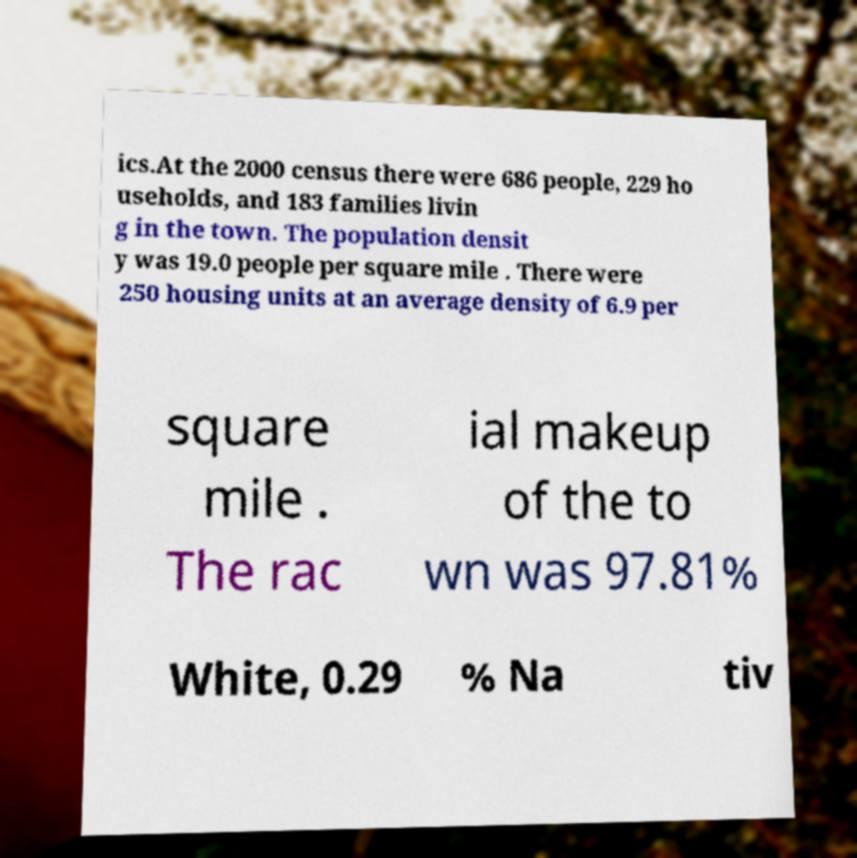Can you read and provide the text displayed in the image?This photo seems to have some interesting text. Can you extract and type it out for me? ics.At the 2000 census there were 686 people, 229 ho useholds, and 183 families livin g in the town. The population densit y was 19.0 people per square mile . There were 250 housing units at an average density of 6.9 per square mile . The rac ial makeup of the to wn was 97.81% White, 0.29 % Na tiv 